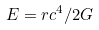<formula> <loc_0><loc_0><loc_500><loc_500>E = r c ^ { 4 } / 2 G</formula> 